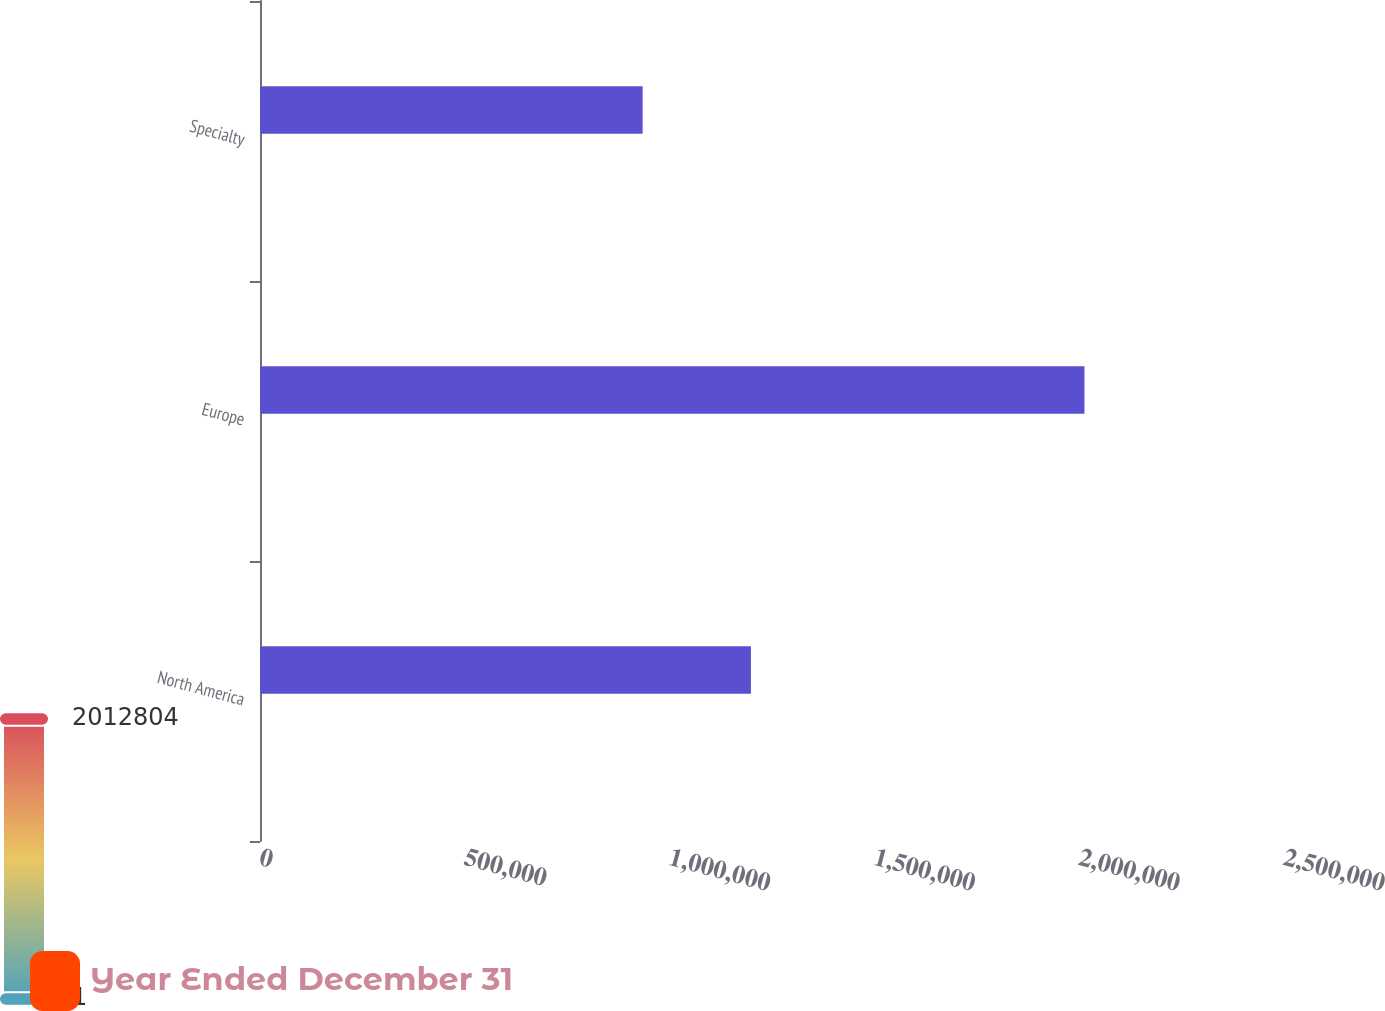Convert chart. <chart><loc_0><loc_0><loc_500><loc_500><stacked_bar_chart><ecel><fcel>North America<fcel>Europe<fcel>Specialty<nl><fcel>nan<fcel>1.19856e+06<fcel>2.0128e+06<fcel>934119<nl><fcel>Year Ended December 31<fcel>1<fcel>2<fcel>3<nl></chart> 